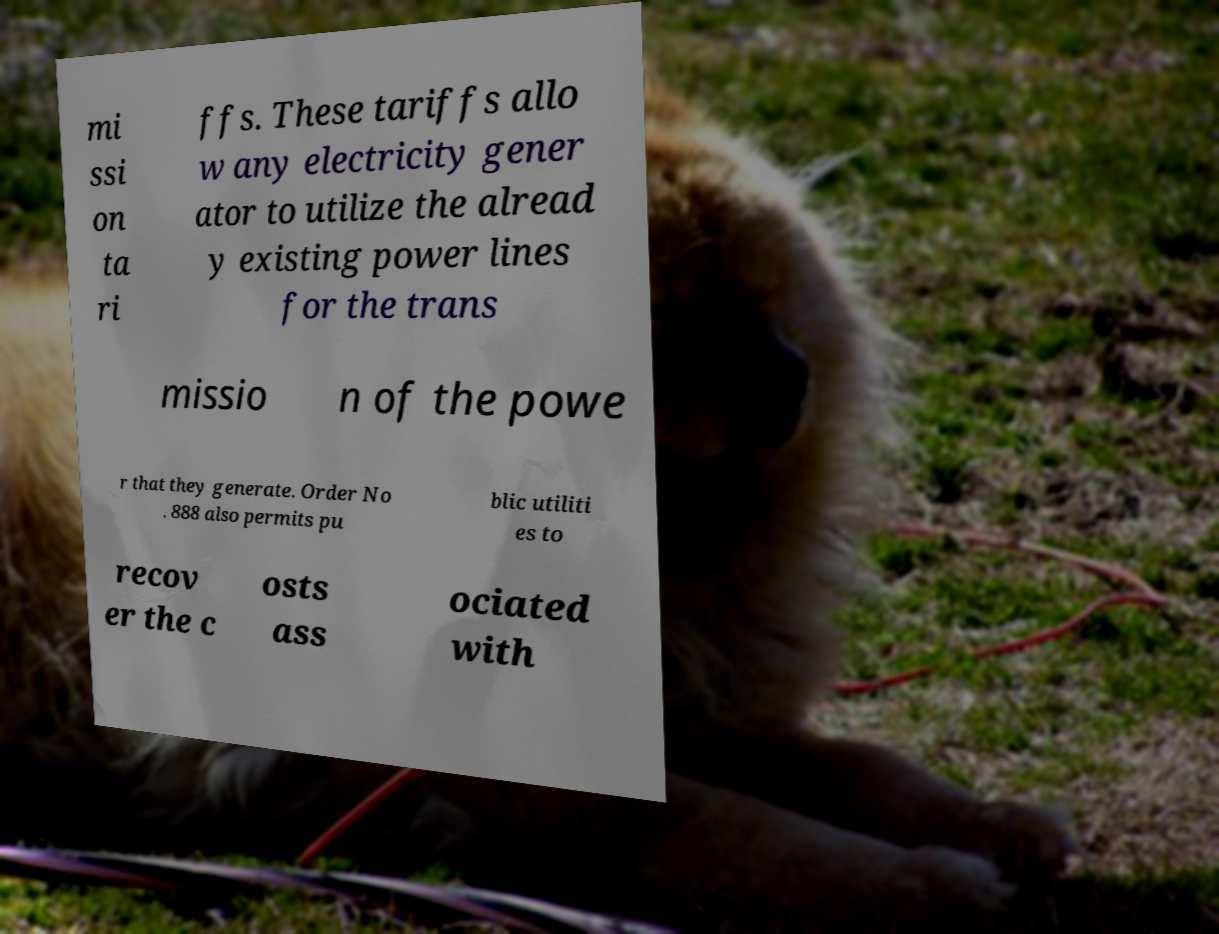Can you read and provide the text displayed in the image?This photo seems to have some interesting text. Can you extract and type it out for me? mi ssi on ta ri ffs. These tariffs allo w any electricity gener ator to utilize the alread y existing power lines for the trans missio n of the powe r that they generate. Order No . 888 also permits pu blic utiliti es to recov er the c osts ass ociated with 